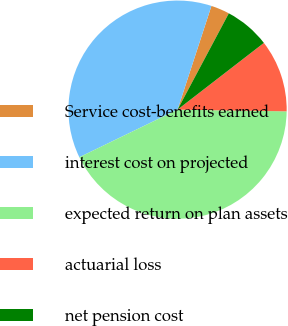Convert chart to OTSL. <chart><loc_0><loc_0><loc_500><loc_500><pie_chart><fcel>Service cost-benefits earned<fcel>interest cost on projected<fcel>expected return on plan assets<fcel>actuarial loss<fcel>net pension cost<nl><fcel>2.76%<fcel>37.2%<fcel>42.57%<fcel>10.72%<fcel>6.74%<nl></chart> 